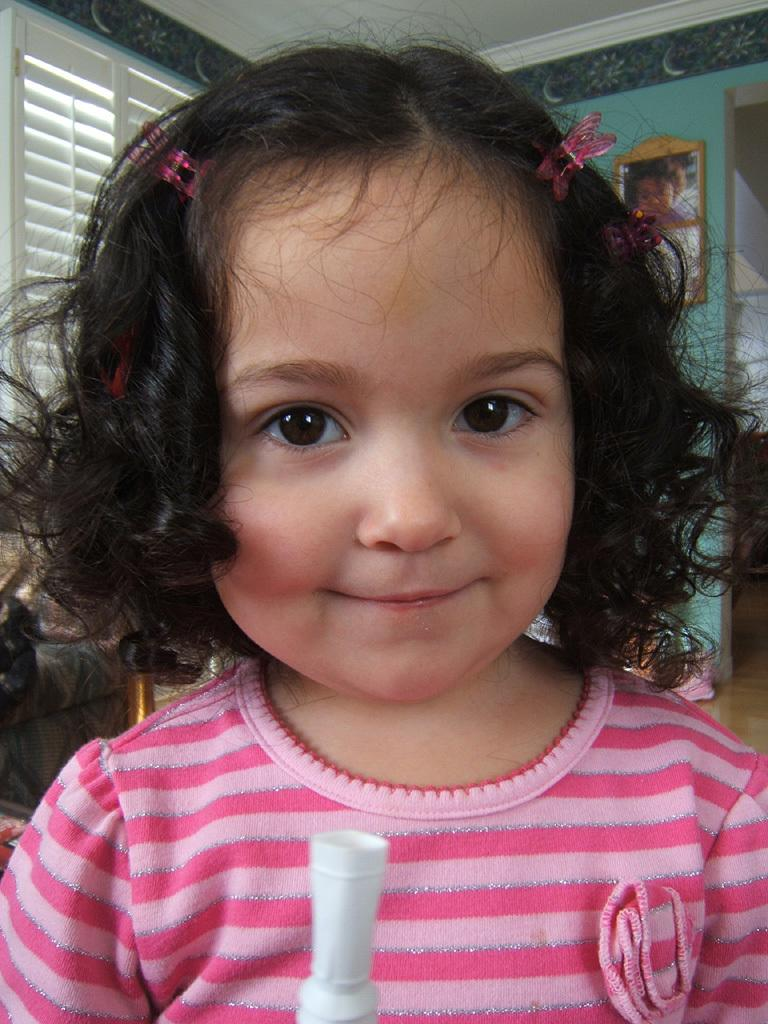Who is the main subject in the image? There is a little girl in the image. What is the girl wearing? The girl is wearing a pink dress. Where is the girl positioned in the image? The girl is standing in the front of the image. What can be seen on the wall in the image? There is a photograph on the wall in the image. What is visible on the left side of the image? There is a window on the left side of the image. What book is the girl reading in the image? There is no book present in the image; the girl is simply standing in front of the wall and window. 